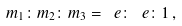Convert formula to latex. <formula><loc_0><loc_0><loc_500><loc_500>m _ { 1 } \colon m _ { 2 } \colon m _ { 3 } = \ e \colon \ e \colon 1 \, ,</formula> 